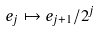Convert formula to latex. <formula><loc_0><loc_0><loc_500><loc_500>e _ { j } \mapsto e _ { j + 1 } / 2 ^ { j }</formula> 